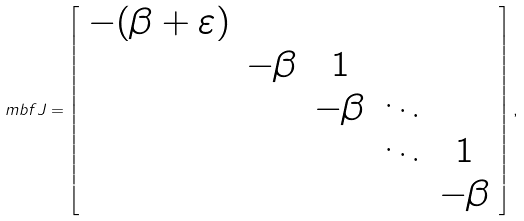Convert formula to latex. <formula><loc_0><loc_0><loc_500><loc_500>\ m b f { J } = \left [ \begin{array} { c c c c c } - ( \beta + \varepsilon ) & & & & \\ & - \beta & 1 & & \\ & & - \beta & \ddots & \\ & & & \ddots & 1 \\ & & & & - \beta \end{array} \right ] ,</formula> 